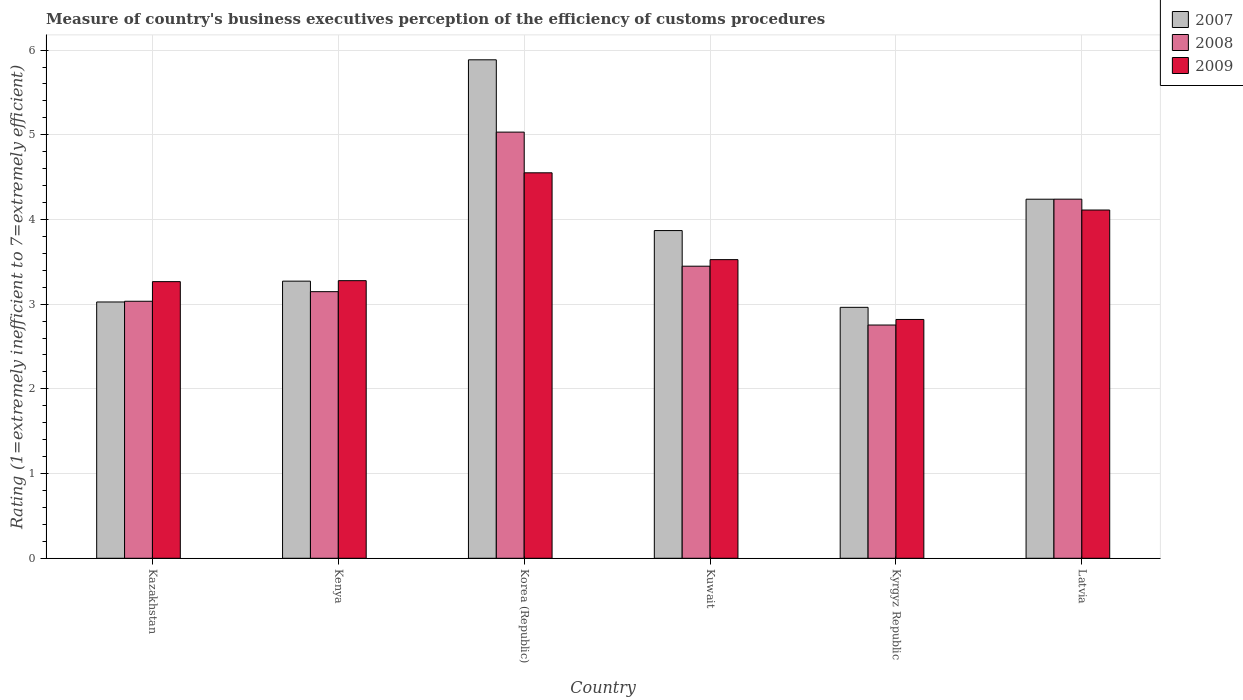How many different coloured bars are there?
Give a very brief answer. 3. Are the number of bars per tick equal to the number of legend labels?
Your answer should be compact. Yes. How many bars are there on the 6th tick from the left?
Your response must be concise. 3. How many bars are there on the 5th tick from the right?
Provide a short and direct response. 3. What is the label of the 3rd group of bars from the left?
Make the answer very short. Korea (Republic). What is the rating of the efficiency of customs procedure in 2007 in Latvia?
Your answer should be very brief. 4.24. Across all countries, what is the maximum rating of the efficiency of customs procedure in 2008?
Make the answer very short. 5.03. Across all countries, what is the minimum rating of the efficiency of customs procedure in 2008?
Your answer should be very brief. 2.75. In which country was the rating of the efficiency of customs procedure in 2008 maximum?
Your response must be concise. Korea (Republic). In which country was the rating of the efficiency of customs procedure in 2009 minimum?
Keep it short and to the point. Kyrgyz Republic. What is the total rating of the efficiency of customs procedure in 2008 in the graph?
Your response must be concise. 21.66. What is the difference between the rating of the efficiency of customs procedure in 2008 in Korea (Republic) and that in Kuwait?
Your answer should be compact. 1.58. What is the difference between the rating of the efficiency of customs procedure in 2007 in Kuwait and the rating of the efficiency of customs procedure in 2009 in Korea (Republic)?
Keep it short and to the point. -0.68. What is the average rating of the efficiency of customs procedure in 2009 per country?
Give a very brief answer. 3.59. What is the difference between the rating of the efficiency of customs procedure of/in 2009 and rating of the efficiency of customs procedure of/in 2008 in Korea (Republic)?
Offer a very short reply. -0.48. In how many countries, is the rating of the efficiency of customs procedure in 2007 greater than 2.8?
Your answer should be very brief. 6. What is the ratio of the rating of the efficiency of customs procedure in 2009 in Kyrgyz Republic to that in Latvia?
Provide a short and direct response. 0.69. Is the rating of the efficiency of customs procedure in 2007 in Kenya less than that in Latvia?
Provide a short and direct response. Yes. Is the difference between the rating of the efficiency of customs procedure in 2009 in Kuwait and Kyrgyz Republic greater than the difference between the rating of the efficiency of customs procedure in 2008 in Kuwait and Kyrgyz Republic?
Ensure brevity in your answer.  Yes. What is the difference between the highest and the second highest rating of the efficiency of customs procedure in 2008?
Offer a very short reply. -0.79. What is the difference between the highest and the lowest rating of the efficiency of customs procedure in 2007?
Give a very brief answer. 2.92. Is the sum of the rating of the efficiency of customs procedure in 2008 in Kazakhstan and Latvia greater than the maximum rating of the efficiency of customs procedure in 2007 across all countries?
Make the answer very short. Yes. What does the 3rd bar from the right in Kuwait represents?
Make the answer very short. 2007. What is the difference between two consecutive major ticks on the Y-axis?
Make the answer very short. 1. Does the graph contain any zero values?
Your answer should be compact. No. How many legend labels are there?
Keep it short and to the point. 3. What is the title of the graph?
Offer a very short reply. Measure of country's business executives perception of the efficiency of customs procedures. What is the label or title of the X-axis?
Keep it short and to the point. Country. What is the label or title of the Y-axis?
Ensure brevity in your answer.  Rating (1=extremely inefficient to 7=extremely efficient). What is the Rating (1=extremely inefficient to 7=extremely efficient) of 2007 in Kazakhstan?
Provide a short and direct response. 3.03. What is the Rating (1=extremely inefficient to 7=extremely efficient) in 2008 in Kazakhstan?
Your answer should be compact. 3.03. What is the Rating (1=extremely inefficient to 7=extremely efficient) in 2009 in Kazakhstan?
Offer a terse response. 3.27. What is the Rating (1=extremely inefficient to 7=extremely efficient) in 2007 in Kenya?
Ensure brevity in your answer.  3.27. What is the Rating (1=extremely inefficient to 7=extremely efficient) of 2008 in Kenya?
Make the answer very short. 3.15. What is the Rating (1=extremely inefficient to 7=extremely efficient) of 2009 in Kenya?
Offer a terse response. 3.28. What is the Rating (1=extremely inefficient to 7=extremely efficient) of 2007 in Korea (Republic)?
Make the answer very short. 5.89. What is the Rating (1=extremely inefficient to 7=extremely efficient) in 2008 in Korea (Republic)?
Provide a succinct answer. 5.03. What is the Rating (1=extremely inefficient to 7=extremely efficient) in 2009 in Korea (Republic)?
Your answer should be very brief. 4.55. What is the Rating (1=extremely inefficient to 7=extremely efficient) of 2007 in Kuwait?
Give a very brief answer. 3.87. What is the Rating (1=extremely inefficient to 7=extremely efficient) in 2008 in Kuwait?
Your answer should be compact. 3.45. What is the Rating (1=extremely inefficient to 7=extremely efficient) in 2009 in Kuwait?
Offer a terse response. 3.53. What is the Rating (1=extremely inefficient to 7=extremely efficient) in 2007 in Kyrgyz Republic?
Offer a very short reply. 2.96. What is the Rating (1=extremely inefficient to 7=extremely efficient) of 2008 in Kyrgyz Republic?
Keep it short and to the point. 2.75. What is the Rating (1=extremely inefficient to 7=extremely efficient) in 2009 in Kyrgyz Republic?
Give a very brief answer. 2.82. What is the Rating (1=extremely inefficient to 7=extremely efficient) in 2007 in Latvia?
Offer a very short reply. 4.24. What is the Rating (1=extremely inefficient to 7=extremely efficient) of 2008 in Latvia?
Ensure brevity in your answer.  4.24. What is the Rating (1=extremely inefficient to 7=extremely efficient) of 2009 in Latvia?
Offer a very short reply. 4.11. Across all countries, what is the maximum Rating (1=extremely inefficient to 7=extremely efficient) of 2007?
Keep it short and to the point. 5.89. Across all countries, what is the maximum Rating (1=extremely inefficient to 7=extremely efficient) of 2008?
Provide a succinct answer. 5.03. Across all countries, what is the maximum Rating (1=extremely inefficient to 7=extremely efficient) of 2009?
Provide a succinct answer. 4.55. Across all countries, what is the minimum Rating (1=extremely inefficient to 7=extremely efficient) in 2007?
Your answer should be compact. 2.96. Across all countries, what is the minimum Rating (1=extremely inefficient to 7=extremely efficient) in 2008?
Offer a very short reply. 2.75. Across all countries, what is the minimum Rating (1=extremely inefficient to 7=extremely efficient) in 2009?
Your answer should be compact. 2.82. What is the total Rating (1=extremely inefficient to 7=extremely efficient) in 2007 in the graph?
Provide a short and direct response. 23.25. What is the total Rating (1=extremely inefficient to 7=extremely efficient) of 2008 in the graph?
Make the answer very short. 21.66. What is the total Rating (1=extremely inefficient to 7=extremely efficient) in 2009 in the graph?
Offer a very short reply. 21.55. What is the difference between the Rating (1=extremely inefficient to 7=extremely efficient) of 2007 in Kazakhstan and that in Kenya?
Your answer should be compact. -0.25. What is the difference between the Rating (1=extremely inefficient to 7=extremely efficient) of 2008 in Kazakhstan and that in Kenya?
Give a very brief answer. -0.11. What is the difference between the Rating (1=extremely inefficient to 7=extremely efficient) in 2009 in Kazakhstan and that in Kenya?
Provide a short and direct response. -0.01. What is the difference between the Rating (1=extremely inefficient to 7=extremely efficient) in 2007 in Kazakhstan and that in Korea (Republic)?
Offer a very short reply. -2.86. What is the difference between the Rating (1=extremely inefficient to 7=extremely efficient) in 2008 in Kazakhstan and that in Korea (Republic)?
Your answer should be compact. -2. What is the difference between the Rating (1=extremely inefficient to 7=extremely efficient) of 2009 in Kazakhstan and that in Korea (Republic)?
Give a very brief answer. -1.28. What is the difference between the Rating (1=extremely inefficient to 7=extremely efficient) in 2007 in Kazakhstan and that in Kuwait?
Provide a succinct answer. -0.84. What is the difference between the Rating (1=extremely inefficient to 7=extremely efficient) in 2008 in Kazakhstan and that in Kuwait?
Offer a terse response. -0.41. What is the difference between the Rating (1=extremely inefficient to 7=extremely efficient) in 2009 in Kazakhstan and that in Kuwait?
Make the answer very short. -0.26. What is the difference between the Rating (1=extremely inefficient to 7=extremely efficient) in 2007 in Kazakhstan and that in Kyrgyz Republic?
Your answer should be compact. 0.06. What is the difference between the Rating (1=extremely inefficient to 7=extremely efficient) in 2008 in Kazakhstan and that in Kyrgyz Republic?
Ensure brevity in your answer.  0.28. What is the difference between the Rating (1=extremely inefficient to 7=extremely efficient) in 2009 in Kazakhstan and that in Kyrgyz Republic?
Provide a succinct answer. 0.45. What is the difference between the Rating (1=extremely inefficient to 7=extremely efficient) in 2007 in Kazakhstan and that in Latvia?
Your answer should be very brief. -1.21. What is the difference between the Rating (1=extremely inefficient to 7=extremely efficient) in 2008 in Kazakhstan and that in Latvia?
Ensure brevity in your answer.  -1.21. What is the difference between the Rating (1=extremely inefficient to 7=extremely efficient) of 2009 in Kazakhstan and that in Latvia?
Your response must be concise. -0.85. What is the difference between the Rating (1=extremely inefficient to 7=extremely efficient) of 2007 in Kenya and that in Korea (Republic)?
Offer a very short reply. -2.61. What is the difference between the Rating (1=extremely inefficient to 7=extremely efficient) in 2008 in Kenya and that in Korea (Republic)?
Your answer should be very brief. -1.88. What is the difference between the Rating (1=extremely inefficient to 7=extremely efficient) in 2009 in Kenya and that in Korea (Republic)?
Make the answer very short. -1.27. What is the difference between the Rating (1=extremely inefficient to 7=extremely efficient) of 2007 in Kenya and that in Kuwait?
Your answer should be very brief. -0.6. What is the difference between the Rating (1=extremely inefficient to 7=extremely efficient) of 2008 in Kenya and that in Kuwait?
Your answer should be very brief. -0.3. What is the difference between the Rating (1=extremely inefficient to 7=extremely efficient) in 2009 in Kenya and that in Kuwait?
Your answer should be compact. -0.25. What is the difference between the Rating (1=extremely inefficient to 7=extremely efficient) of 2007 in Kenya and that in Kyrgyz Republic?
Offer a very short reply. 0.31. What is the difference between the Rating (1=extremely inefficient to 7=extremely efficient) of 2008 in Kenya and that in Kyrgyz Republic?
Ensure brevity in your answer.  0.39. What is the difference between the Rating (1=extremely inefficient to 7=extremely efficient) in 2009 in Kenya and that in Kyrgyz Republic?
Keep it short and to the point. 0.46. What is the difference between the Rating (1=extremely inefficient to 7=extremely efficient) in 2007 in Kenya and that in Latvia?
Ensure brevity in your answer.  -0.97. What is the difference between the Rating (1=extremely inefficient to 7=extremely efficient) of 2008 in Kenya and that in Latvia?
Ensure brevity in your answer.  -1.09. What is the difference between the Rating (1=extremely inefficient to 7=extremely efficient) of 2009 in Kenya and that in Latvia?
Provide a short and direct response. -0.83. What is the difference between the Rating (1=extremely inefficient to 7=extremely efficient) in 2007 in Korea (Republic) and that in Kuwait?
Provide a short and direct response. 2.02. What is the difference between the Rating (1=extremely inefficient to 7=extremely efficient) of 2008 in Korea (Republic) and that in Kuwait?
Provide a short and direct response. 1.58. What is the difference between the Rating (1=extremely inefficient to 7=extremely efficient) of 2009 in Korea (Republic) and that in Kuwait?
Give a very brief answer. 1.03. What is the difference between the Rating (1=extremely inefficient to 7=extremely efficient) of 2007 in Korea (Republic) and that in Kyrgyz Republic?
Your response must be concise. 2.92. What is the difference between the Rating (1=extremely inefficient to 7=extremely efficient) in 2008 in Korea (Republic) and that in Kyrgyz Republic?
Your answer should be compact. 2.28. What is the difference between the Rating (1=extremely inefficient to 7=extremely efficient) of 2009 in Korea (Republic) and that in Kyrgyz Republic?
Give a very brief answer. 1.73. What is the difference between the Rating (1=extremely inefficient to 7=extremely efficient) of 2007 in Korea (Republic) and that in Latvia?
Keep it short and to the point. 1.65. What is the difference between the Rating (1=extremely inefficient to 7=extremely efficient) in 2008 in Korea (Republic) and that in Latvia?
Offer a very short reply. 0.79. What is the difference between the Rating (1=extremely inefficient to 7=extremely efficient) of 2009 in Korea (Republic) and that in Latvia?
Your answer should be very brief. 0.44. What is the difference between the Rating (1=extremely inefficient to 7=extremely efficient) of 2007 in Kuwait and that in Kyrgyz Republic?
Keep it short and to the point. 0.91. What is the difference between the Rating (1=extremely inefficient to 7=extremely efficient) in 2008 in Kuwait and that in Kyrgyz Republic?
Make the answer very short. 0.69. What is the difference between the Rating (1=extremely inefficient to 7=extremely efficient) in 2009 in Kuwait and that in Kyrgyz Republic?
Provide a short and direct response. 0.71. What is the difference between the Rating (1=extremely inefficient to 7=extremely efficient) in 2007 in Kuwait and that in Latvia?
Your answer should be compact. -0.37. What is the difference between the Rating (1=extremely inefficient to 7=extremely efficient) of 2008 in Kuwait and that in Latvia?
Your answer should be compact. -0.79. What is the difference between the Rating (1=extremely inefficient to 7=extremely efficient) of 2009 in Kuwait and that in Latvia?
Offer a very short reply. -0.59. What is the difference between the Rating (1=extremely inefficient to 7=extremely efficient) of 2007 in Kyrgyz Republic and that in Latvia?
Provide a short and direct response. -1.28. What is the difference between the Rating (1=extremely inefficient to 7=extremely efficient) in 2008 in Kyrgyz Republic and that in Latvia?
Your answer should be compact. -1.49. What is the difference between the Rating (1=extremely inefficient to 7=extremely efficient) in 2009 in Kyrgyz Republic and that in Latvia?
Provide a short and direct response. -1.29. What is the difference between the Rating (1=extremely inefficient to 7=extremely efficient) of 2007 in Kazakhstan and the Rating (1=extremely inefficient to 7=extremely efficient) of 2008 in Kenya?
Ensure brevity in your answer.  -0.12. What is the difference between the Rating (1=extremely inefficient to 7=extremely efficient) of 2007 in Kazakhstan and the Rating (1=extremely inefficient to 7=extremely efficient) of 2009 in Kenya?
Offer a very short reply. -0.25. What is the difference between the Rating (1=extremely inefficient to 7=extremely efficient) of 2008 in Kazakhstan and the Rating (1=extremely inefficient to 7=extremely efficient) of 2009 in Kenya?
Give a very brief answer. -0.24. What is the difference between the Rating (1=extremely inefficient to 7=extremely efficient) of 2007 in Kazakhstan and the Rating (1=extremely inefficient to 7=extremely efficient) of 2008 in Korea (Republic)?
Make the answer very short. -2.01. What is the difference between the Rating (1=extremely inefficient to 7=extremely efficient) in 2007 in Kazakhstan and the Rating (1=extremely inefficient to 7=extremely efficient) in 2009 in Korea (Republic)?
Provide a succinct answer. -1.53. What is the difference between the Rating (1=extremely inefficient to 7=extremely efficient) of 2008 in Kazakhstan and the Rating (1=extremely inefficient to 7=extremely efficient) of 2009 in Korea (Republic)?
Give a very brief answer. -1.52. What is the difference between the Rating (1=extremely inefficient to 7=extremely efficient) in 2007 in Kazakhstan and the Rating (1=extremely inefficient to 7=extremely efficient) in 2008 in Kuwait?
Provide a short and direct response. -0.42. What is the difference between the Rating (1=extremely inefficient to 7=extremely efficient) of 2007 in Kazakhstan and the Rating (1=extremely inefficient to 7=extremely efficient) of 2009 in Kuwait?
Your answer should be compact. -0.5. What is the difference between the Rating (1=extremely inefficient to 7=extremely efficient) in 2008 in Kazakhstan and the Rating (1=extremely inefficient to 7=extremely efficient) in 2009 in Kuwait?
Make the answer very short. -0.49. What is the difference between the Rating (1=extremely inefficient to 7=extremely efficient) in 2007 in Kazakhstan and the Rating (1=extremely inefficient to 7=extremely efficient) in 2008 in Kyrgyz Republic?
Provide a short and direct response. 0.27. What is the difference between the Rating (1=extremely inefficient to 7=extremely efficient) in 2007 in Kazakhstan and the Rating (1=extremely inefficient to 7=extremely efficient) in 2009 in Kyrgyz Republic?
Provide a succinct answer. 0.21. What is the difference between the Rating (1=extremely inefficient to 7=extremely efficient) in 2008 in Kazakhstan and the Rating (1=extremely inefficient to 7=extremely efficient) in 2009 in Kyrgyz Republic?
Your answer should be compact. 0.21. What is the difference between the Rating (1=extremely inefficient to 7=extremely efficient) in 2007 in Kazakhstan and the Rating (1=extremely inefficient to 7=extremely efficient) in 2008 in Latvia?
Keep it short and to the point. -1.21. What is the difference between the Rating (1=extremely inefficient to 7=extremely efficient) of 2007 in Kazakhstan and the Rating (1=extremely inefficient to 7=extremely efficient) of 2009 in Latvia?
Provide a succinct answer. -1.09. What is the difference between the Rating (1=extremely inefficient to 7=extremely efficient) in 2008 in Kazakhstan and the Rating (1=extremely inefficient to 7=extremely efficient) in 2009 in Latvia?
Make the answer very short. -1.08. What is the difference between the Rating (1=extremely inefficient to 7=extremely efficient) in 2007 in Kenya and the Rating (1=extremely inefficient to 7=extremely efficient) in 2008 in Korea (Republic)?
Keep it short and to the point. -1.76. What is the difference between the Rating (1=extremely inefficient to 7=extremely efficient) of 2007 in Kenya and the Rating (1=extremely inefficient to 7=extremely efficient) of 2009 in Korea (Republic)?
Ensure brevity in your answer.  -1.28. What is the difference between the Rating (1=extremely inefficient to 7=extremely efficient) of 2008 in Kenya and the Rating (1=extremely inefficient to 7=extremely efficient) of 2009 in Korea (Republic)?
Make the answer very short. -1.4. What is the difference between the Rating (1=extremely inefficient to 7=extremely efficient) of 2007 in Kenya and the Rating (1=extremely inefficient to 7=extremely efficient) of 2008 in Kuwait?
Your answer should be very brief. -0.18. What is the difference between the Rating (1=extremely inefficient to 7=extremely efficient) in 2007 in Kenya and the Rating (1=extremely inefficient to 7=extremely efficient) in 2009 in Kuwait?
Offer a terse response. -0.25. What is the difference between the Rating (1=extremely inefficient to 7=extremely efficient) in 2008 in Kenya and the Rating (1=extremely inefficient to 7=extremely efficient) in 2009 in Kuwait?
Your response must be concise. -0.38. What is the difference between the Rating (1=extremely inefficient to 7=extremely efficient) in 2007 in Kenya and the Rating (1=extremely inefficient to 7=extremely efficient) in 2008 in Kyrgyz Republic?
Give a very brief answer. 0.52. What is the difference between the Rating (1=extremely inefficient to 7=extremely efficient) in 2007 in Kenya and the Rating (1=extremely inefficient to 7=extremely efficient) in 2009 in Kyrgyz Republic?
Provide a succinct answer. 0.45. What is the difference between the Rating (1=extremely inefficient to 7=extremely efficient) in 2008 in Kenya and the Rating (1=extremely inefficient to 7=extremely efficient) in 2009 in Kyrgyz Republic?
Keep it short and to the point. 0.33. What is the difference between the Rating (1=extremely inefficient to 7=extremely efficient) in 2007 in Kenya and the Rating (1=extremely inefficient to 7=extremely efficient) in 2008 in Latvia?
Make the answer very short. -0.97. What is the difference between the Rating (1=extremely inefficient to 7=extremely efficient) of 2007 in Kenya and the Rating (1=extremely inefficient to 7=extremely efficient) of 2009 in Latvia?
Your answer should be very brief. -0.84. What is the difference between the Rating (1=extremely inefficient to 7=extremely efficient) in 2008 in Kenya and the Rating (1=extremely inefficient to 7=extremely efficient) in 2009 in Latvia?
Ensure brevity in your answer.  -0.96. What is the difference between the Rating (1=extremely inefficient to 7=extremely efficient) in 2007 in Korea (Republic) and the Rating (1=extremely inefficient to 7=extremely efficient) in 2008 in Kuwait?
Provide a succinct answer. 2.44. What is the difference between the Rating (1=extremely inefficient to 7=extremely efficient) of 2007 in Korea (Republic) and the Rating (1=extremely inefficient to 7=extremely efficient) of 2009 in Kuwait?
Provide a succinct answer. 2.36. What is the difference between the Rating (1=extremely inefficient to 7=extremely efficient) of 2008 in Korea (Republic) and the Rating (1=extremely inefficient to 7=extremely efficient) of 2009 in Kuwait?
Provide a succinct answer. 1.51. What is the difference between the Rating (1=extremely inefficient to 7=extremely efficient) of 2007 in Korea (Republic) and the Rating (1=extremely inefficient to 7=extremely efficient) of 2008 in Kyrgyz Republic?
Offer a terse response. 3.13. What is the difference between the Rating (1=extremely inefficient to 7=extremely efficient) of 2007 in Korea (Republic) and the Rating (1=extremely inefficient to 7=extremely efficient) of 2009 in Kyrgyz Republic?
Make the answer very short. 3.07. What is the difference between the Rating (1=extremely inefficient to 7=extremely efficient) of 2008 in Korea (Republic) and the Rating (1=extremely inefficient to 7=extremely efficient) of 2009 in Kyrgyz Republic?
Offer a very short reply. 2.21. What is the difference between the Rating (1=extremely inefficient to 7=extremely efficient) of 2007 in Korea (Republic) and the Rating (1=extremely inefficient to 7=extremely efficient) of 2008 in Latvia?
Provide a short and direct response. 1.65. What is the difference between the Rating (1=extremely inefficient to 7=extremely efficient) of 2007 in Korea (Republic) and the Rating (1=extremely inefficient to 7=extremely efficient) of 2009 in Latvia?
Give a very brief answer. 1.77. What is the difference between the Rating (1=extremely inefficient to 7=extremely efficient) of 2008 in Korea (Republic) and the Rating (1=extremely inefficient to 7=extremely efficient) of 2009 in Latvia?
Keep it short and to the point. 0.92. What is the difference between the Rating (1=extremely inefficient to 7=extremely efficient) in 2007 in Kuwait and the Rating (1=extremely inefficient to 7=extremely efficient) in 2008 in Kyrgyz Republic?
Give a very brief answer. 1.11. What is the difference between the Rating (1=extremely inefficient to 7=extremely efficient) of 2007 in Kuwait and the Rating (1=extremely inefficient to 7=extremely efficient) of 2009 in Kyrgyz Republic?
Keep it short and to the point. 1.05. What is the difference between the Rating (1=extremely inefficient to 7=extremely efficient) of 2008 in Kuwait and the Rating (1=extremely inefficient to 7=extremely efficient) of 2009 in Kyrgyz Republic?
Provide a succinct answer. 0.63. What is the difference between the Rating (1=extremely inefficient to 7=extremely efficient) in 2007 in Kuwait and the Rating (1=extremely inefficient to 7=extremely efficient) in 2008 in Latvia?
Provide a short and direct response. -0.37. What is the difference between the Rating (1=extremely inefficient to 7=extremely efficient) in 2007 in Kuwait and the Rating (1=extremely inefficient to 7=extremely efficient) in 2009 in Latvia?
Keep it short and to the point. -0.24. What is the difference between the Rating (1=extremely inefficient to 7=extremely efficient) in 2008 in Kuwait and the Rating (1=extremely inefficient to 7=extremely efficient) in 2009 in Latvia?
Your answer should be very brief. -0.66. What is the difference between the Rating (1=extremely inefficient to 7=extremely efficient) of 2007 in Kyrgyz Republic and the Rating (1=extremely inefficient to 7=extremely efficient) of 2008 in Latvia?
Provide a short and direct response. -1.28. What is the difference between the Rating (1=extremely inefficient to 7=extremely efficient) of 2007 in Kyrgyz Republic and the Rating (1=extremely inefficient to 7=extremely efficient) of 2009 in Latvia?
Your answer should be very brief. -1.15. What is the difference between the Rating (1=extremely inefficient to 7=extremely efficient) of 2008 in Kyrgyz Republic and the Rating (1=extremely inefficient to 7=extremely efficient) of 2009 in Latvia?
Your answer should be compact. -1.36. What is the average Rating (1=extremely inefficient to 7=extremely efficient) in 2007 per country?
Your answer should be compact. 3.88. What is the average Rating (1=extremely inefficient to 7=extremely efficient) of 2008 per country?
Provide a succinct answer. 3.61. What is the average Rating (1=extremely inefficient to 7=extremely efficient) of 2009 per country?
Offer a very short reply. 3.59. What is the difference between the Rating (1=extremely inefficient to 7=extremely efficient) of 2007 and Rating (1=extremely inefficient to 7=extremely efficient) of 2008 in Kazakhstan?
Ensure brevity in your answer.  -0.01. What is the difference between the Rating (1=extremely inefficient to 7=extremely efficient) in 2007 and Rating (1=extremely inefficient to 7=extremely efficient) in 2009 in Kazakhstan?
Keep it short and to the point. -0.24. What is the difference between the Rating (1=extremely inefficient to 7=extremely efficient) of 2008 and Rating (1=extremely inefficient to 7=extremely efficient) of 2009 in Kazakhstan?
Give a very brief answer. -0.23. What is the difference between the Rating (1=extremely inefficient to 7=extremely efficient) of 2007 and Rating (1=extremely inefficient to 7=extremely efficient) of 2008 in Kenya?
Your answer should be compact. 0.12. What is the difference between the Rating (1=extremely inefficient to 7=extremely efficient) of 2007 and Rating (1=extremely inefficient to 7=extremely efficient) of 2009 in Kenya?
Provide a short and direct response. -0.01. What is the difference between the Rating (1=extremely inefficient to 7=extremely efficient) in 2008 and Rating (1=extremely inefficient to 7=extremely efficient) in 2009 in Kenya?
Your answer should be very brief. -0.13. What is the difference between the Rating (1=extremely inefficient to 7=extremely efficient) of 2007 and Rating (1=extremely inefficient to 7=extremely efficient) of 2008 in Korea (Republic)?
Ensure brevity in your answer.  0.85. What is the difference between the Rating (1=extremely inefficient to 7=extremely efficient) in 2007 and Rating (1=extremely inefficient to 7=extremely efficient) in 2009 in Korea (Republic)?
Make the answer very short. 1.33. What is the difference between the Rating (1=extremely inefficient to 7=extremely efficient) in 2008 and Rating (1=extremely inefficient to 7=extremely efficient) in 2009 in Korea (Republic)?
Your answer should be very brief. 0.48. What is the difference between the Rating (1=extremely inefficient to 7=extremely efficient) of 2007 and Rating (1=extremely inefficient to 7=extremely efficient) of 2008 in Kuwait?
Keep it short and to the point. 0.42. What is the difference between the Rating (1=extremely inefficient to 7=extremely efficient) of 2007 and Rating (1=extremely inefficient to 7=extremely efficient) of 2009 in Kuwait?
Your answer should be compact. 0.34. What is the difference between the Rating (1=extremely inefficient to 7=extremely efficient) in 2008 and Rating (1=extremely inefficient to 7=extremely efficient) in 2009 in Kuwait?
Provide a short and direct response. -0.08. What is the difference between the Rating (1=extremely inefficient to 7=extremely efficient) of 2007 and Rating (1=extremely inefficient to 7=extremely efficient) of 2008 in Kyrgyz Republic?
Ensure brevity in your answer.  0.21. What is the difference between the Rating (1=extremely inefficient to 7=extremely efficient) of 2007 and Rating (1=extremely inefficient to 7=extremely efficient) of 2009 in Kyrgyz Republic?
Your answer should be compact. 0.14. What is the difference between the Rating (1=extremely inefficient to 7=extremely efficient) in 2008 and Rating (1=extremely inefficient to 7=extremely efficient) in 2009 in Kyrgyz Republic?
Your answer should be compact. -0.07. What is the difference between the Rating (1=extremely inefficient to 7=extremely efficient) in 2007 and Rating (1=extremely inefficient to 7=extremely efficient) in 2008 in Latvia?
Make the answer very short. -0. What is the difference between the Rating (1=extremely inefficient to 7=extremely efficient) in 2007 and Rating (1=extremely inefficient to 7=extremely efficient) in 2009 in Latvia?
Ensure brevity in your answer.  0.13. What is the difference between the Rating (1=extremely inefficient to 7=extremely efficient) in 2008 and Rating (1=extremely inefficient to 7=extremely efficient) in 2009 in Latvia?
Offer a terse response. 0.13. What is the ratio of the Rating (1=extremely inefficient to 7=extremely efficient) in 2007 in Kazakhstan to that in Kenya?
Give a very brief answer. 0.92. What is the ratio of the Rating (1=extremely inefficient to 7=extremely efficient) in 2008 in Kazakhstan to that in Kenya?
Ensure brevity in your answer.  0.96. What is the ratio of the Rating (1=extremely inefficient to 7=extremely efficient) in 2007 in Kazakhstan to that in Korea (Republic)?
Offer a very short reply. 0.51. What is the ratio of the Rating (1=extremely inefficient to 7=extremely efficient) of 2008 in Kazakhstan to that in Korea (Republic)?
Give a very brief answer. 0.6. What is the ratio of the Rating (1=extremely inefficient to 7=extremely efficient) in 2009 in Kazakhstan to that in Korea (Republic)?
Keep it short and to the point. 0.72. What is the ratio of the Rating (1=extremely inefficient to 7=extremely efficient) of 2007 in Kazakhstan to that in Kuwait?
Give a very brief answer. 0.78. What is the ratio of the Rating (1=extremely inefficient to 7=extremely efficient) in 2008 in Kazakhstan to that in Kuwait?
Keep it short and to the point. 0.88. What is the ratio of the Rating (1=extremely inefficient to 7=extremely efficient) of 2009 in Kazakhstan to that in Kuwait?
Give a very brief answer. 0.93. What is the ratio of the Rating (1=extremely inefficient to 7=extremely efficient) in 2007 in Kazakhstan to that in Kyrgyz Republic?
Your response must be concise. 1.02. What is the ratio of the Rating (1=extremely inefficient to 7=extremely efficient) in 2008 in Kazakhstan to that in Kyrgyz Republic?
Your response must be concise. 1.1. What is the ratio of the Rating (1=extremely inefficient to 7=extremely efficient) in 2009 in Kazakhstan to that in Kyrgyz Republic?
Keep it short and to the point. 1.16. What is the ratio of the Rating (1=extremely inefficient to 7=extremely efficient) in 2007 in Kazakhstan to that in Latvia?
Your answer should be compact. 0.71. What is the ratio of the Rating (1=extremely inefficient to 7=extremely efficient) of 2008 in Kazakhstan to that in Latvia?
Offer a very short reply. 0.72. What is the ratio of the Rating (1=extremely inefficient to 7=extremely efficient) in 2009 in Kazakhstan to that in Latvia?
Provide a short and direct response. 0.79. What is the ratio of the Rating (1=extremely inefficient to 7=extremely efficient) of 2007 in Kenya to that in Korea (Republic)?
Give a very brief answer. 0.56. What is the ratio of the Rating (1=extremely inefficient to 7=extremely efficient) in 2008 in Kenya to that in Korea (Republic)?
Your response must be concise. 0.63. What is the ratio of the Rating (1=extremely inefficient to 7=extremely efficient) of 2009 in Kenya to that in Korea (Republic)?
Ensure brevity in your answer.  0.72. What is the ratio of the Rating (1=extremely inefficient to 7=extremely efficient) of 2007 in Kenya to that in Kuwait?
Your answer should be compact. 0.85. What is the ratio of the Rating (1=extremely inefficient to 7=extremely efficient) of 2008 in Kenya to that in Kuwait?
Ensure brevity in your answer.  0.91. What is the ratio of the Rating (1=extremely inefficient to 7=extremely efficient) in 2009 in Kenya to that in Kuwait?
Offer a terse response. 0.93. What is the ratio of the Rating (1=extremely inefficient to 7=extremely efficient) of 2007 in Kenya to that in Kyrgyz Republic?
Your answer should be very brief. 1.1. What is the ratio of the Rating (1=extremely inefficient to 7=extremely efficient) in 2008 in Kenya to that in Kyrgyz Republic?
Give a very brief answer. 1.14. What is the ratio of the Rating (1=extremely inefficient to 7=extremely efficient) of 2009 in Kenya to that in Kyrgyz Republic?
Provide a succinct answer. 1.16. What is the ratio of the Rating (1=extremely inefficient to 7=extremely efficient) of 2007 in Kenya to that in Latvia?
Provide a succinct answer. 0.77. What is the ratio of the Rating (1=extremely inefficient to 7=extremely efficient) in 2008 in Kenya to that in Latvia?
Keep it short and to the point. 0.74. What is the ratio of the Rating (1=extremely inefficient to 7=extremely efficient) of 2009 in Kenya to that in Latvia?
Your response must be concise. 0.8. What is the ratio of the Rating (1=extremely inefficient to 7=extremely efficient) of 2007 in Korea (Republic) to that in Kuwait?
Your answer should be very brief. 1.52. What is the ratio of the Rating (1=extremely inefficient to 7=extremely efficient) of 2008 in Korea (Republic) to that in Kuwait?
Offer a very short reply. 1.46. What is the ratio of the Rating (1=extremely inefficient to 7=extremely efficient) of 2009 in Korea (Republic) to that in Kuwait?
Your answer should be compact. 1.29. What is the ratio of the Rating (1=extremely inefficient to 7=extremely efficient) in 2007 in Korea (Republic) to that in Kyrgyz Republic?
Offer a terse response. 1.99. What is the ratio of the Rating (1=extremely inefficient to 7=extremely efficient) of 2008 in Korea (Republic) to that in Kyrgyz Republic?
Make the answer very short. 1.83. What is the ratio of the Rating (1=extremely inefficient to 7=extremely efficient) in 2009 in Korea (Republic) to that in Kyrgyz Republic?
Your answer should be very brief. 1.61. What is the ratio of the Rating (1=extremely inefficient to 7=extremely efficient) in 2007 in Korea (Republic) to that in Latvia?
Ensure brevity in your answer.  1.39. What is the ratio of the Rating (1=extremely inefficient to 7=extremely efficient) in 2008 in Korea (Republic) to that in Latvia?
Ensure brevity in your answer.  1.19. What is the ratio of the Rating (1=extremely inefficient to 7=extremely efficient) in 2009 in Korea (Republic) to that in Latvia?
Ensure brevity in your answer.  1.11. What is the ratio of the Rating (1=extremely inefficient to 7=extremely efficient) of 2007 in Kuwait to that in Kyrgyz Republic?
Your answer should be compact. 1.31. What is the ratio of the Rating (1=extremely inefficient to 7=extremely efficient) of 2008 in Kuwait to that in Kyrgyz Republic?
Your answer should be compact. 1.25. What is the ratio of the Rating (1=extremely inefficient to 7=extremely efficient) of 2009 in Kuwait to that in Kyrgyz Republic?
Provide a short and direct response. 1.25. What is the ratio of the Rating (1=extremely inefficient to 7=extremely efficient) in 2007 in Kuwait to that in Latvia?
Make the answer very short. 0.91. What is the ratio of the Rating (1=extremely inefficient to 7=extremely efficient) in 2008 in Kuwait to that in Latvia?
Keep it short and to the point. 0.81. What is the ratio of the Rating (1=extremely inefficient to 7=extremely efficient) in 2009 in Kuwait to that in Latvia?
Offer a very short reply. 0.86. What is the ratio of the Rating (1=extremely inefficient to 7=extremely efficient) in 2007 in Kyrgyz Republic to that in Latvia?
Keep it short and to the point. 0.7. What is the ratio of the Rating (1=extremely inefficient to 7=extremely efficient) in 2008 in Kyrgyz Republic to that in Latvia?
Offer a very short reply. 0.65. What is the ratio of the Rating (1=extremely inefficient to 7=extremely efficient) in 2009 in Kyrgyz Republic to that in Latvia?
Your answer should be compact. 0.69. What is the difference between the highest and the second highest Rating (1=extremely inefficient to 7=extremely efficient) of 2007?
Ensure brevity in your answer.  1.65. What is the difference between the highest and the second highest Rating (1=extremely inefficient to 7=extremely efficient) of 2008?
Your response must be concise. 0.79. What is the difference between the highest and the second highest Rating (1=extremely inefficient to 7=extremely efficient) in 2009?
Provide a short and direct response. 0.44. What is the difference between the highest and the lowest Rating (1=extremely inefficient to 7=extremely efficient) in 2007?
Your answer should be compact. 2.92. What is the difference between the highest and the lowest Rating (1=extremely inefficient to 7=extremely efficient) in 2008?
Offer a very short reply. 2.28. What is the difference between the highest and the lowest Rating (1=extremely inefficient to 7=extremely efficient) of 2009?
Make the answer very short. 1.73. 